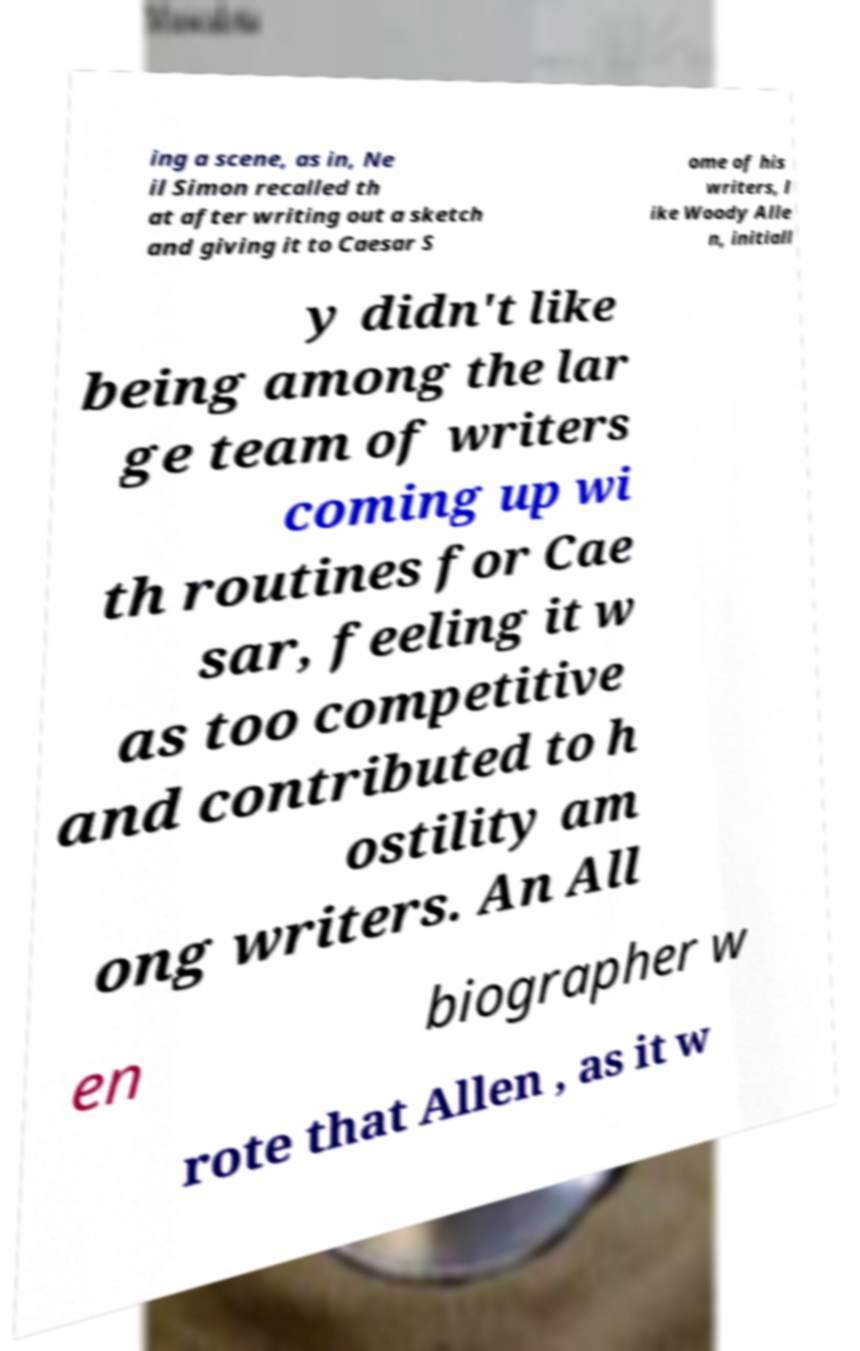I need the written content from this picture converted into text. Can you do that? ing a scene, as in, Ne il Simon recalled th at after writing out a sketch and giving it to Caesar S ome of his writers, l ike Woody Alle n, initiall y didn't like being among the lar ge team of writers coming up wi th routines for Cae sar, feeling it w as too competitive and contributed to h ostility am ong writers. An All en biographer w rote that Allen , as it w 